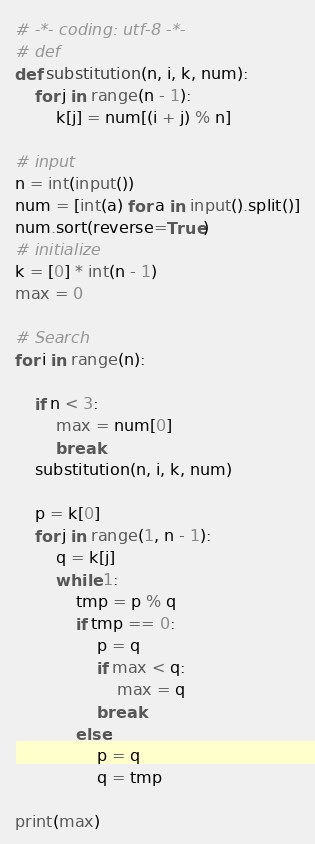Convert code to text. <code><loc_0><loc_0><loc_500><loc_500><_Python_># -*- coding: utf-8 -*-
# def
def substitution(n, i, k, num):
    for j in range(n - 1):
        k[j] = num[(i + j) % n]

# input
n = int(input())
num = [int(a) for a in input().split()]
num.sort(reverse=True)
# initialize
k = [0] * int(n - 1)
max = 0

# Search
for i in range(n):

    if n < 3:
        max = num[0]
        break
    substitution(n, i, k, num)

    p = k[0]
    for j in range(1, n - 1):
        q = k[j]
        while 1:
            tmp = p % q
            if tmp == 0:
                p = q
                if max < q:
                    max = q
                break
            else:
                p = q
                q = tmp

print(max)
</code> 